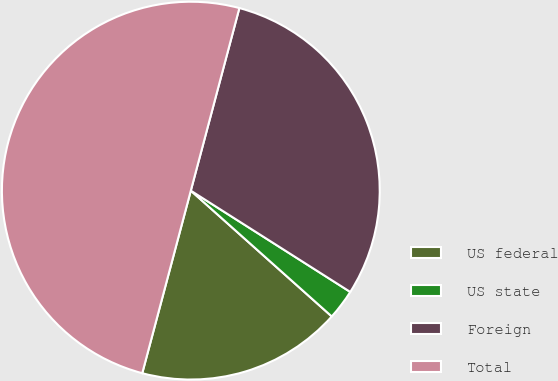<chart> <loc_0><loc_0><loc_500><loc_500><pie_chart><fcel>US federal<fcel>US state<fcel>Foreign<fcel>Total<nl><fcel>17.54%<fcel>2.59%<fcel>29.87%<fcel>50.0%<nl></chart> 